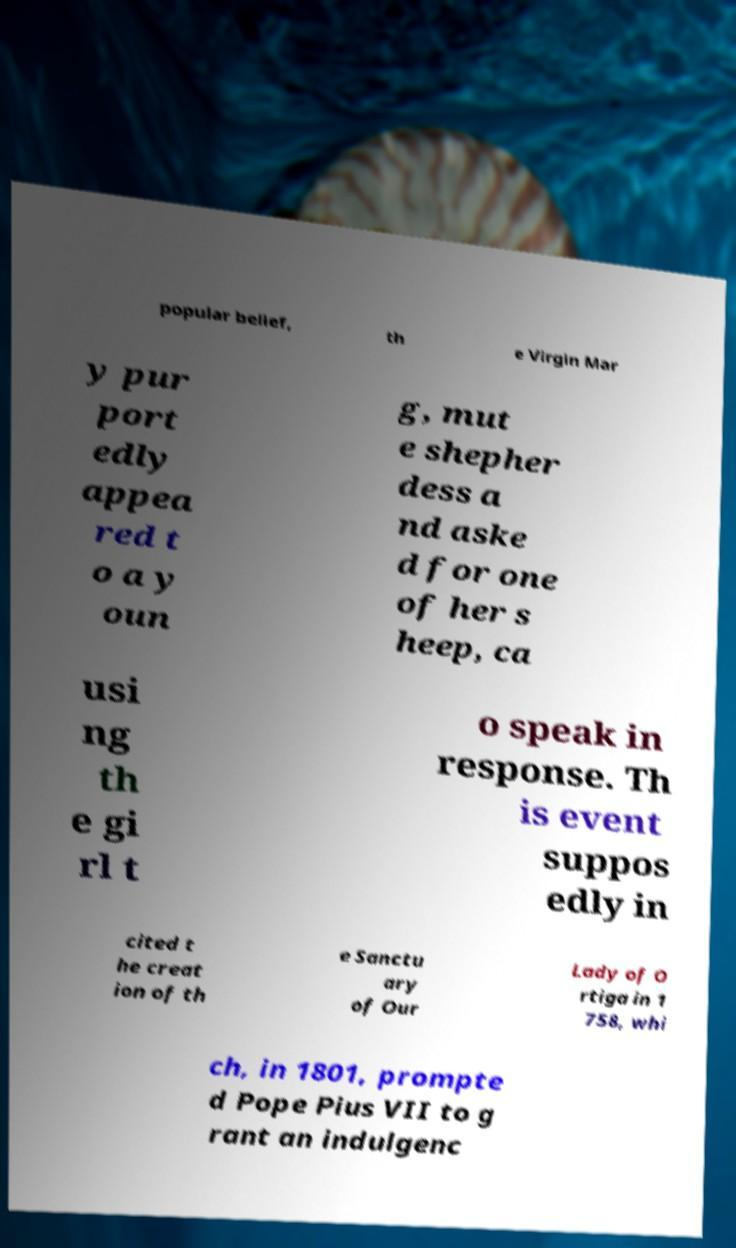Please read and relay the text visible in this image. What does it say? popular belief, th e Virgin Mar y pur port edly appea red t o a y oun g, mut e shepher dess a nd aske d for one of her s heep, ca usi ng th e gi rl t o speak in response. Th is event suppos edly in cited t he creat ion of th e Sanctu ary of Our Lady of O rtiga in 1 758, whi ch, in 1801, prompte d Pope Pius VII to g rant an indulgenc 